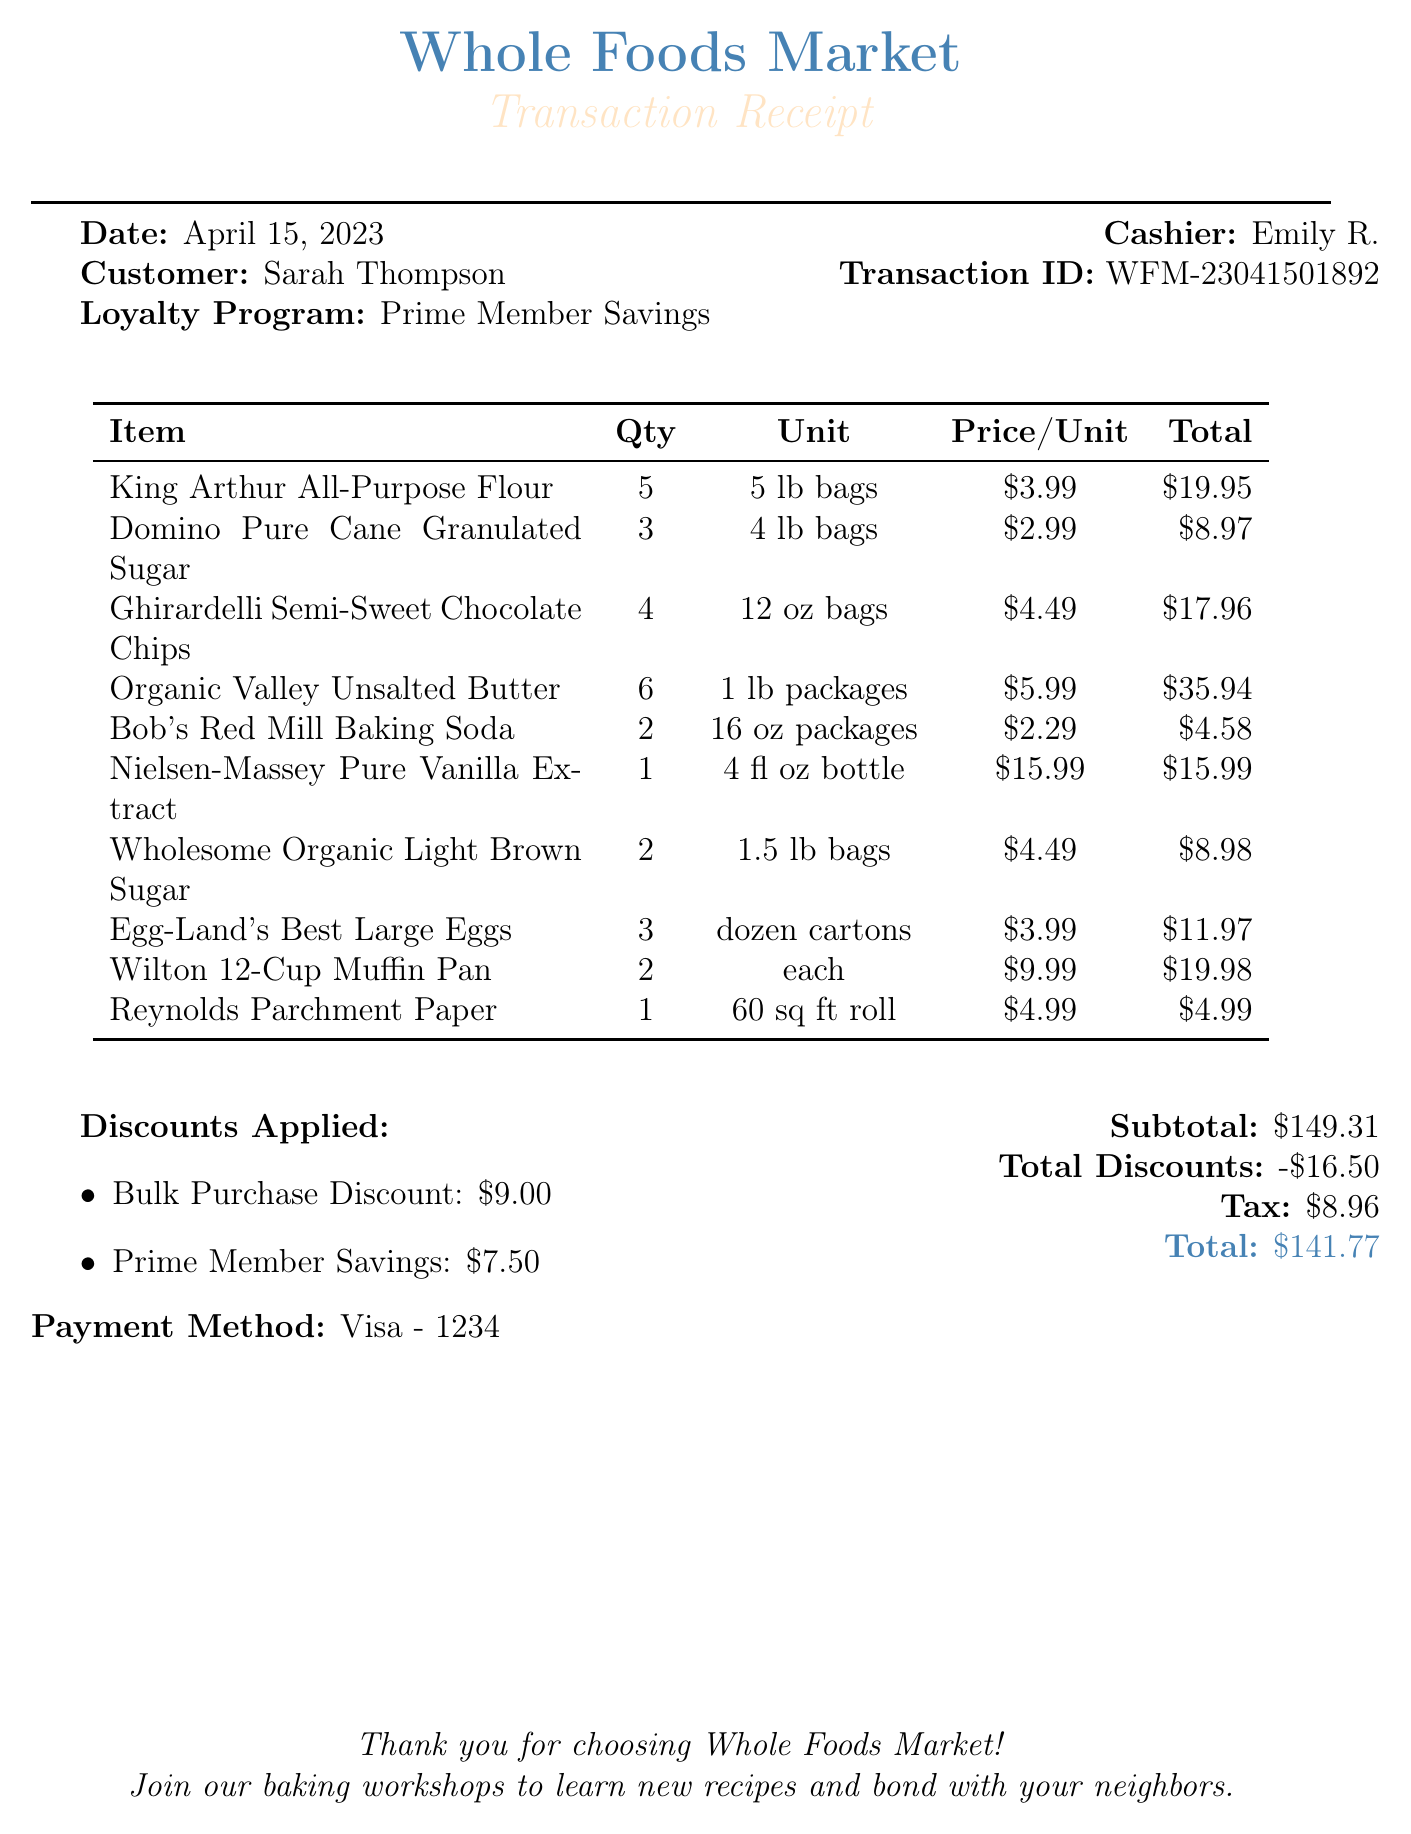What is the store name? The store name is provided at the top of the document.
Answer: Whole Foods Market What is the date of the transaction? The date is mentioned in the header section of the document.
Answer: April 15, 2023 How many bags of King Arthur All-Purpose Flour were purchased? The quantity is specified next to the item name in the receipt table.
Answer: 5 What is the total bulk discount applied? The total bulk discount is listed in the discounts section near the bottom of the document.
Answer: 9.00 What is the total amount spent after discounts? The total amount is found at the very end of the document.
Answer: 141.77 What is the loyalty program used for this transaction? The loyalty program is mentioned in the header section of the document.
Answer: Prime Member Savings How many items had a loyalty discount applied? The items with loyalty discounts are specified in the discounts section, requiring evaluation of the individual items listed.
Answer: 3 What was the price per unit for Organic Valley Unsalted Butter? The price per unit is listed for each item in the receipt table.
Answer: 5.99 Who was the cashier for this transaction? The cashier's name is provided in the header section of the receipt.
Answer: Emily R What is the transaction ID? The transaction ID is specified in the document's header section.
Answer: WFM-23041501892 